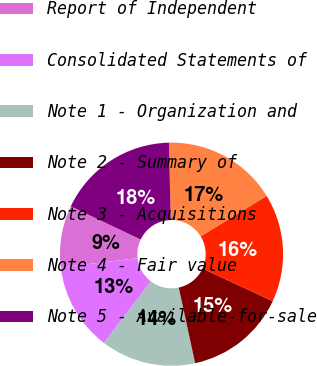Convert chart to OTSL. <chart><loc_0><loc_0><loc_500><loc_500><pie_chart><fcel>Report of Independent<fcel>Consolidated Statements of<fcel>Note 1 - Organization and<fcel>Note 2 - Summary of<fcel>Note 3 - Acquisitions<fcel>Note 4 - Fair value<fcel>Note 5 - Available-for-sale<nl><fcel>8.94%<fcel>12.78%<fcel>13.74%<fcel>14.7%<fcel>15.66%<fcel>16.62%<fcel>17.58%<nl></chart> 